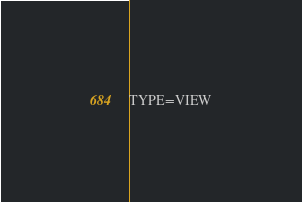Convert code to text. <code><loc_0><loc_0><loc_500><loc_500><_VisualBasic_>TYPE=VIEW</code> 